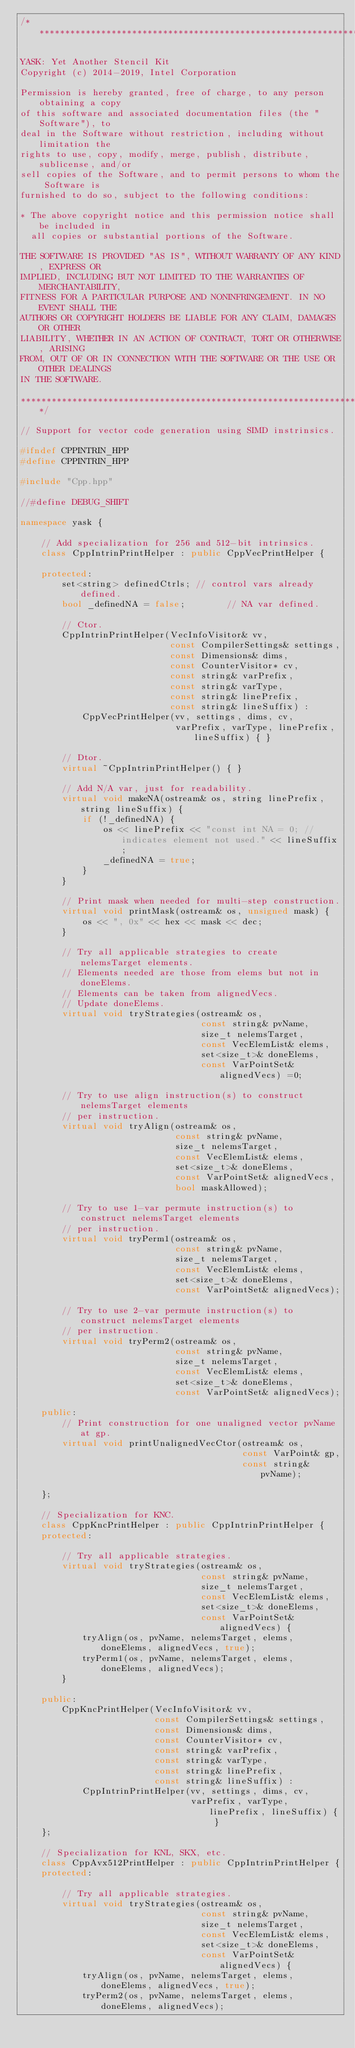<code> <loc_0><loc_0><loc_500><loc_500><_C++_>/*****************************************************************************

YASK: Yet Another Stencil Kit
Copyright (c) 2014-2019, Intel Corporation

Permission is hereby granted, free of charge, to any person obtaining a copy
of this software and associated documentation files (the "Software"), to
deal in the Software without restriction, including without limitation the
rights to use, copy, modify, merge, publish, distribute, sublicense, and/or
sell copies of the Software, and to permit persons to whom the Software is
furnished to do so, subject to the following conditions:

* The above copyright notice and this permission notice shall be included in
  all copies or substantial portions of the Software.

THE SOFTWARE IS PROVIDED "AS IS", WITHOUT WARRANTY OF ANY KIND, EXPRESS OR
IMPLIED, INCLUDING BUT NOT LIMITED TO THE WARRANTIES OF MERCHANTABILITY,
FITNESS FOR A PARTICULAR PURPOSE AND NONINFRINGEMENT. IN NO EVENT SHALL THE
AUTHORS OR COPYRIGHT HOLDERS BE LIABLE FOR ANY CLAIM, DAMAGES OR OTHER
LIABILITY, WHETHER IN AN ACTION OF CONTRACT, TORT OR OTHERWISE, ARISING
FROM, OUT OF OR IN CONNECTION WITH THE SOFTWARE OR THE USE OR OTHER DEALINGS
IN THE SOFTWARE.

*****************************************************************************/

// Support for vector code generation using SIMD instrinsics.

#ifndef CPPINTRIN_HPP
#define CPPINTRIN_HPP

#include "Cpp.hpp"

//#define DEBUG_SHIFT

namespace yask {

    // Add specialization for 256 and 512-bit intrinsics.
    class CppIntrinPrintHelper : public CppVecPrintHelper {

    protected:
        set<string> definedCtrls; // control vars already defined.
        bool _definedNA = false;        // NA var defined.

        // Ctor.
        CppIntrinPrintHelper(VecInfoVisitor& vv,
                             const CompilerSettings& settings,
                             const Dimensions& dims,
                             const CounterVisitor* cv,
                             const string& varPrefix,
                             const string& varType,
                             const string& linePrefix,
                             const string& lineSuffix) :
            CppVecPrintHelper(vv, settings, dims, cv,
                              varPrefix, varType, linePrefix, lineSuffix) { }

        // Dtor.
        virtual ~CppIntrinPrintHelper() { }

        // Add N/A var, just for readability.
        virtual void makeNA(ostream& os, string linePrefix, string lineSuffix) {
            if (!_definedNA) {
                os << linePrefix << "const int NA = 0; // indicates element not used." << lineSuffix;
                _definedNA = true;
            }
        }

        // Print mask when needed for multi-step construction.
        virtual void printMask(ostream& os, unsigned mask) {
            os << ", 0x" << hex << mask << dec;
        }

        // Try all applicable strategies to create nelemsTarget elements.
        // Elements needed are those from elems but not in doneElems.
        // Elements can be taken from alignedVecs.
        // Update doneElems.
        virtual void tryStrategies(ostream& os,
                                   const string& pvName,
                                   size_t nelemsTarget,
                                   const VecElemList& elems,
                                   set<size_t>& doneElems,
                                   const VarPointSet& alignedVecs) =0;

        // Try to use align instruction(s) to construct nelemsTarget elements
        // per instruction.
        virtual void tryAlign(ostream& os,
                              const string& pvName,
                              size_t nelemsTarget,
                              const VecElemList& elems,
                              set<size_t>& doneElems,
                              const VarPointSet& alignedVecs,
                              bool maskAllowed);

        // Try to use 1-var permute instruction(s) to construct nelemsTarget elements
        // per instruction.
        virtual void tryPerm1(ostream& os,
                              const string& pvName,
                              size_t nelemsTarget,
                              const VecElemList& elems,
                              set<size_t>& doneElems,
                              const VarPointSet& alignedVecs);

        // Try to use 2-var permute instruction(s) to construct nelemsTarget elements
        // per instruction.
        virtual void tryPerm2(ostream& os,
                              const string& pvName,
                              size_t nelemsTarget,
                              const VecElemList& elems,
                              set<size_t>& doneElems,
                              const VarPointSet& alignedVecs);

    public:
        // Print construction for one unaligned vector pvName at gp.
        virtual void printUnalignedVecCtor(ostream& os,
                                           const VarPoint& gp,
                                           const string& pvName);

    };

    // Specialization for KNC.
    class CppKncPrintHelper : public CppIntrinPrintHelper {
    protected:

        // Try all applicable strategies.
        virtual void tryStrategies(ostream& os,
                                   const string& pvName,
                                   size_t nelemsTarget,
                                   const VecElemList& elems,
                                   set<size_t>& doneElems,
                                   const VarPointSet& alignedVecs) {
            tryAlign(os, pvName, nelemsTarget, elems, doneElems, alignedVecs, true);
            tryPerm1(os, pvName, nelemsTarget, elems, doneElems, alignedVecs);
        }

    public:
        CppKncPrintHelper(VecInfoVisitor& vv,
                          const CompilerSettings& settings,
                          const Dimensions& dims,
                          const CounterVisitor* cv,
                          const string& varPrefix,
                          const string& varType,
                          const string& linePrefix,
                          const string& lineSuffix) :
            CppIntrinPrintHelper(vv, settings, dims, cv,
                                 varPrefix, varType, linePrefix, lineSuffix) { }
    };

    // Specialization for KNL, SKX, etc.
    class CppAvx512PrintHelper : public CppIntrinPrintHelper {
    protected:

        // Try all applicable strategies.
        virtual void tryStrategies(ostream& os,
                                   const string& pvName,
                                   size_t nelemsTarget,
                                   const VecElemList& elems,
                                   set<size_t>& doneElems,
                                   const VarPointSet& alignedVecs) {
            tryAlign(os, pvName, nelemsTarget, elems, doneElems, alignedVecs, true);
            tryPerm2(os, pvName, nelemsTarget, elems, doneElems, alignedVecs);</code> 